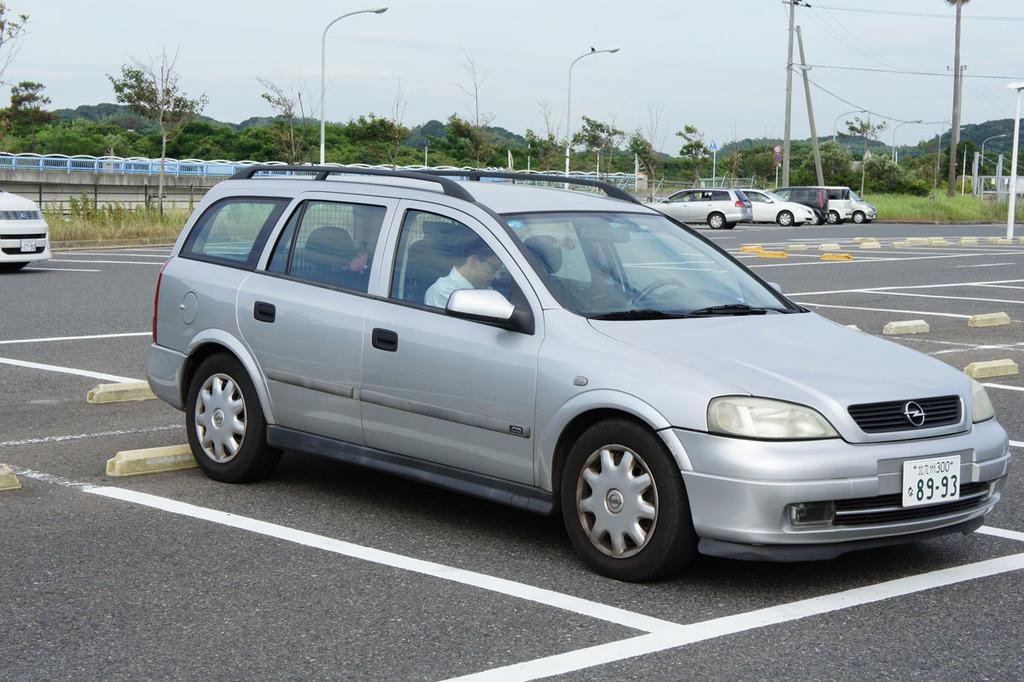What can be seen in the image? There are vehicles in the image, and a person is sitting in one of them. What is visible in the background of the image? Trees, fencing, light poles, current poles, and wires are visible in the background. What is the color of the sky in the image? The sky is blue in color. What type of watch is the person wearing in the image? There is no watch visible on the person in the image. What scent can be detected from the trees in the background? There is no information about the scent of the trees in the image. 